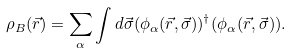Convert formula to latex. <formula><loc_0><loc_0><loc_500><loc_500>\rho _ { B } ( \vec { r } ) = \sum _ { \alpha } \int d \vec { \sigma } ( \phi _ { \alpha } ( \vec { r } , \vec { \sigma } ) ) ^ { \dagger } ( \phi _ { \alpha } ( \vec { r } , \vec { \sigma } ) ) .</formula> 